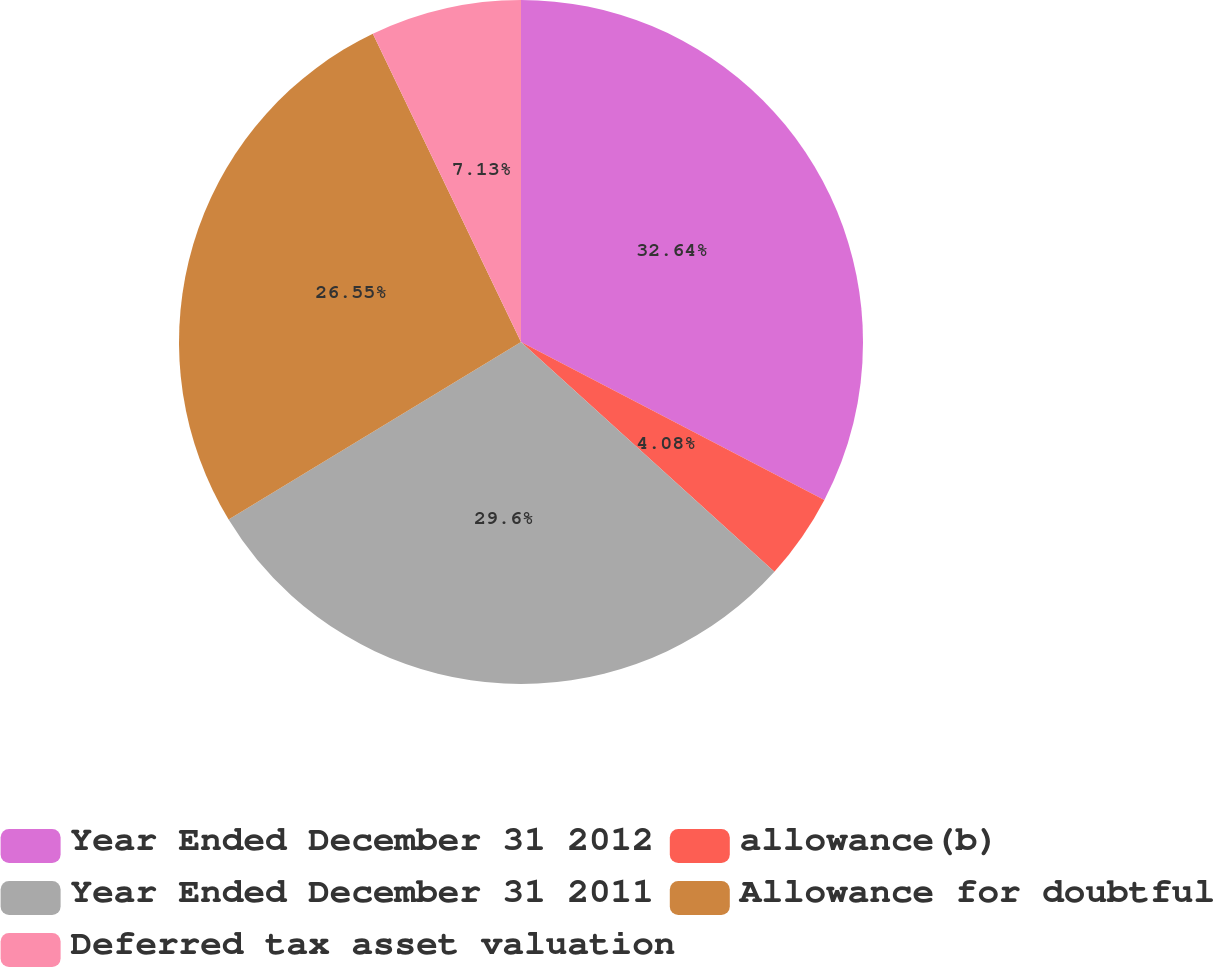<chart> <loc_0><loc_0><loc_500><loc_500><pie_chart><fcel>Year Ended December 31 2012<fcel>allowance(b)<fcel>Year Ended December 31 2011<fcel>Allowance for doubtful<fcel>Deferred tax asset valuation<nl><fcel>32.64%<fcel>4.08%<fcel>29.6%<fcel>26.55%<fcel>7.13%<nl></chart> 